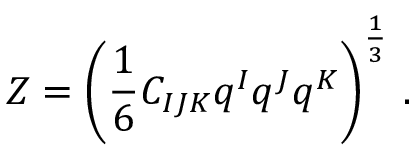Convert formula to latex. <formula><loc_0><loc_0><loc_500><loc_500>Z = \left ( \frac { 1 } { 6 } C _ { I J K } q ^ { I } q ^ { J } q ^ { K } \right ) ^ { \frac { 1 } { 3 } } \, .</formula> 